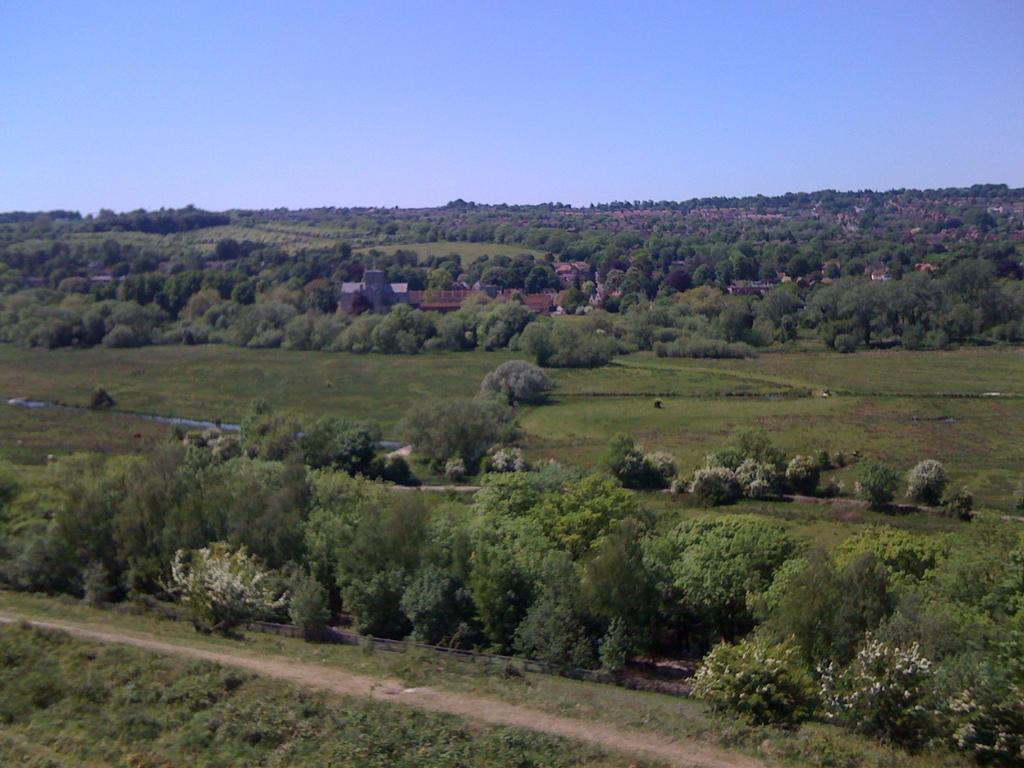Could you give a brief overview of what you see in this image? This is an outside view. In this image, I can see many trees and plants on the ground. At the bottom there is a path. In the middle of the image there is a building. At the top of the image I can see the sky in blue color. 